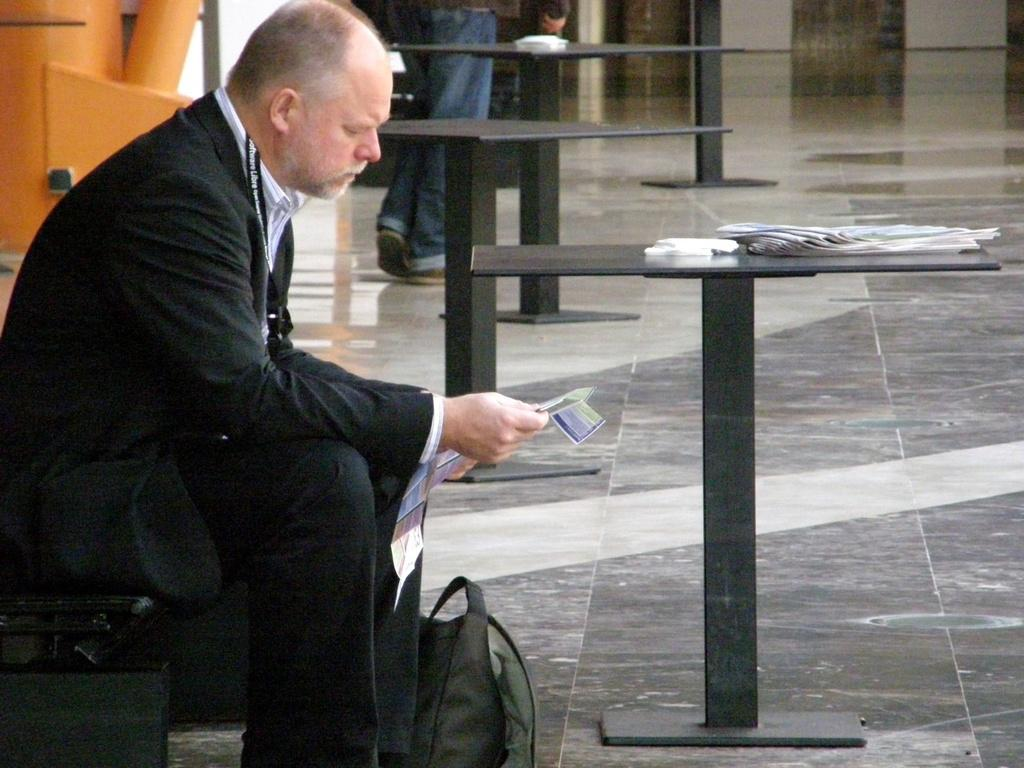What is the person in the image doing? The person is sitting on a chair in the image. What objects are present in the image besides the person? There are tables in the image. Can you describe the activity happening in the background of the image? There is a man walking in the background of the image. What might be used for writing or reading on in the image? There are papers on one of the tables. What type of base can be seen supporting the person in the image? There is no base visible in the image; the person is sitting on a chair. 